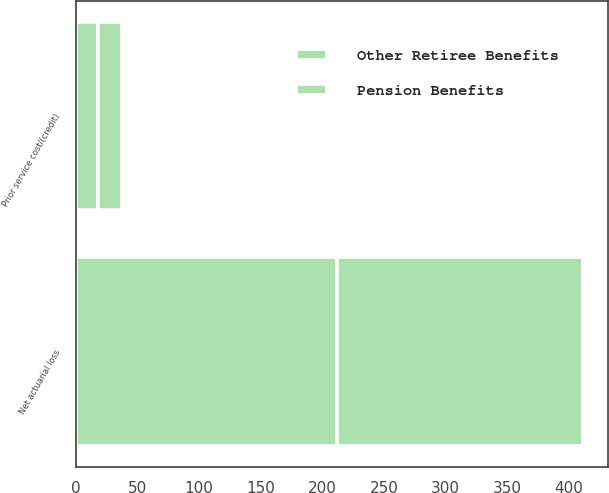Convert chart to OTSL. <chart><loc_0><loc_0><loc_500><loc_500><stacked_bar_chart><ecel><fcel>Net actuarial loss<fcel>Prior service cost/(credit)<nl><fcel>Other Retiree Benefits<fcel>212<fcel>18<nl><fcel>Pension Benefits<fcel>199<fcel>20<nl></chart> 